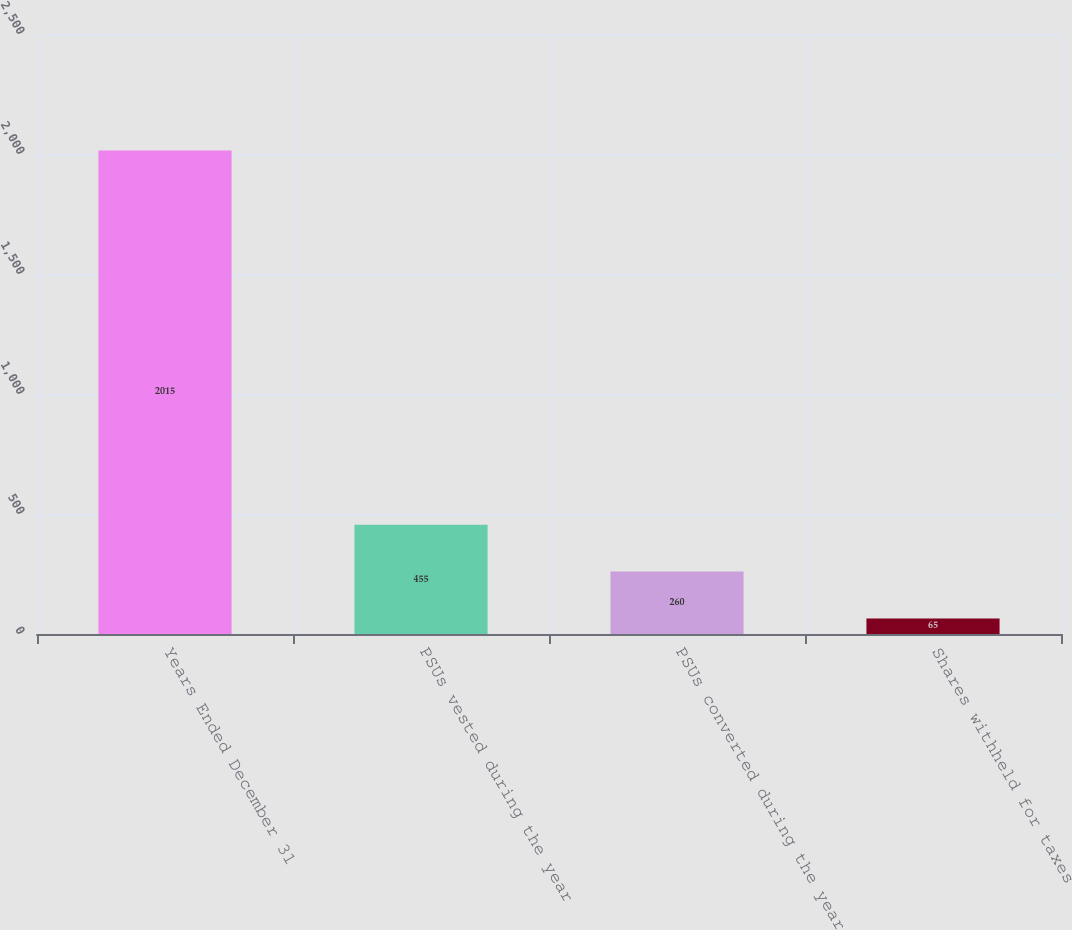Convert chart to OTSL. <chart><loc_0><loc_0><loc_500><loc_500><bar_chart><fcel>Years Ended December 31<fcel>PSUs vested during the year<fcel>PSUs converted during the year<fcel>Shares withheld for taxes<nl><fcel>2015<fcel>455<fcel>260<fcel>65<nl></chart> 